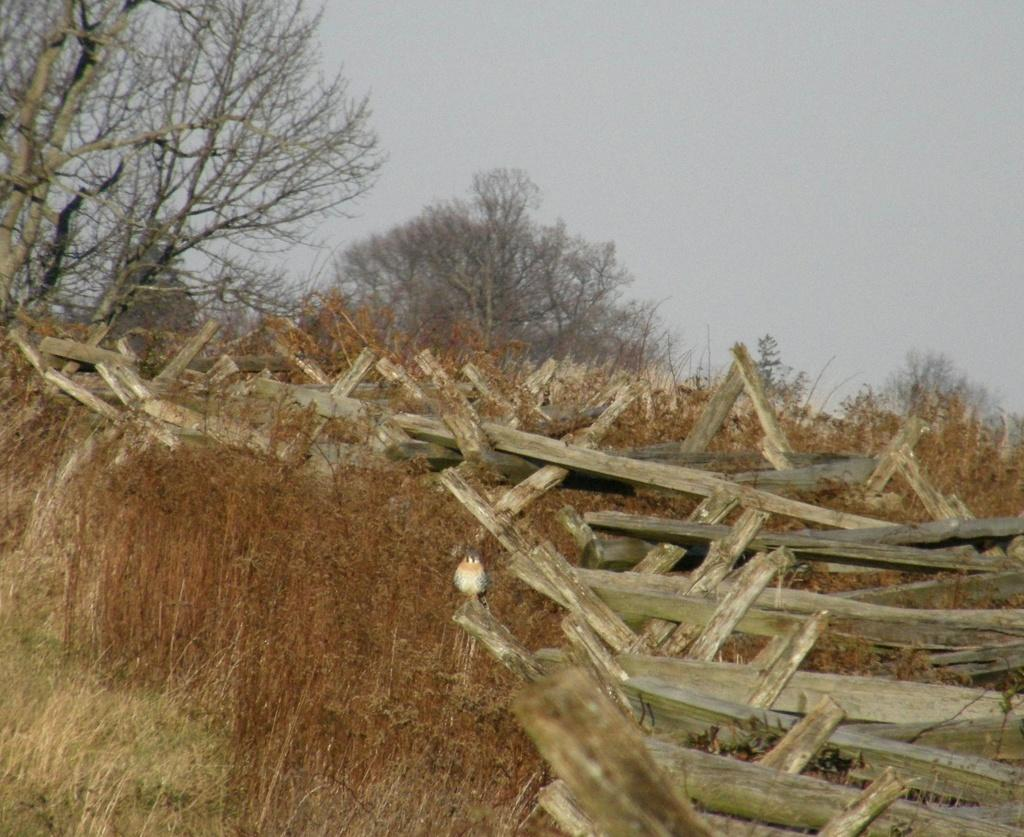What type of objects are in the image? There are wooden sticks in the image. Where are the wooden sticks located? The wooden sticks are placed on the grass. What can be seen in the background of the image? There are trees and the sky visible in the background of the image. What caused the wooden sticks to break in the image? There is no indication in the image that the wooden sticks have broken. --- Facts: 1. There is a person in the image. 2. The person is wearing a hat. 3. The person is holding a book. 4. There is a table in the image. 5. The table has a vase with flowers on it. Absurd Topics: unicorn, piano Conversation: Who or what is in the image? There is a person in the image. What is the person wearing in the image? The person is wearing a hat. What is the person holding in the image? The person is holding a book. What is on the table in the image? There is a vase with flowers on it. Reasoning: Let's think step by step in order to produce the conversation. We start by identifying the main subject in the image, which is the person. Then, we describe specific details about the person, such as the hat and the book they are holding. Next, we mention the table and describe what is on the table. Each question is designed to elicit a specific detail about the image that is known from the provided facts. Absurd Question/Answer: Can you see a unicorn playing the piano in the image? There is no unicorn or piano present in the image. 